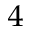<formula> <loc_0><loc_0><loc_500><loc_500>^ { 4 }</formula> 